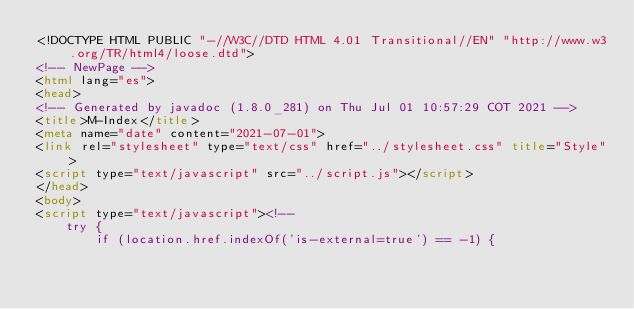Convert code to text. <code><loc_0><loc_0><loc_500><loc_500><_HTML_><!DOCTYPE HTML PUBLIC "-//W3C//DTD HTML 4.01 Transitional//EN" "http://www.w3.org/TR/html4/loose.dtd">
<!-- NewPage -->
<html lang="es">
<head>
<!-- Generated by javadoc (1.8.0_281) on Thu Jul 01 10:57:29 COT 2021 -->
<title>M-Index</title>
<meta name="date" content="2021-07-01">
<link rel="stylesheet" type="text/css" href="../stylesheet.css" title="Style">
<script type="text/javascript" src="../script.js"></script>
</head>
<body>
<script type="text/javascript"><!--
    try {
        if (location.href.indexOf('is-external=true') == -1) {</code> 